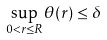<formula> <loc_0><loc_0><loc_500><loc_500>\sup _ { 0 < r \leq R } \theta ( r ) \leq \delta</formula> 